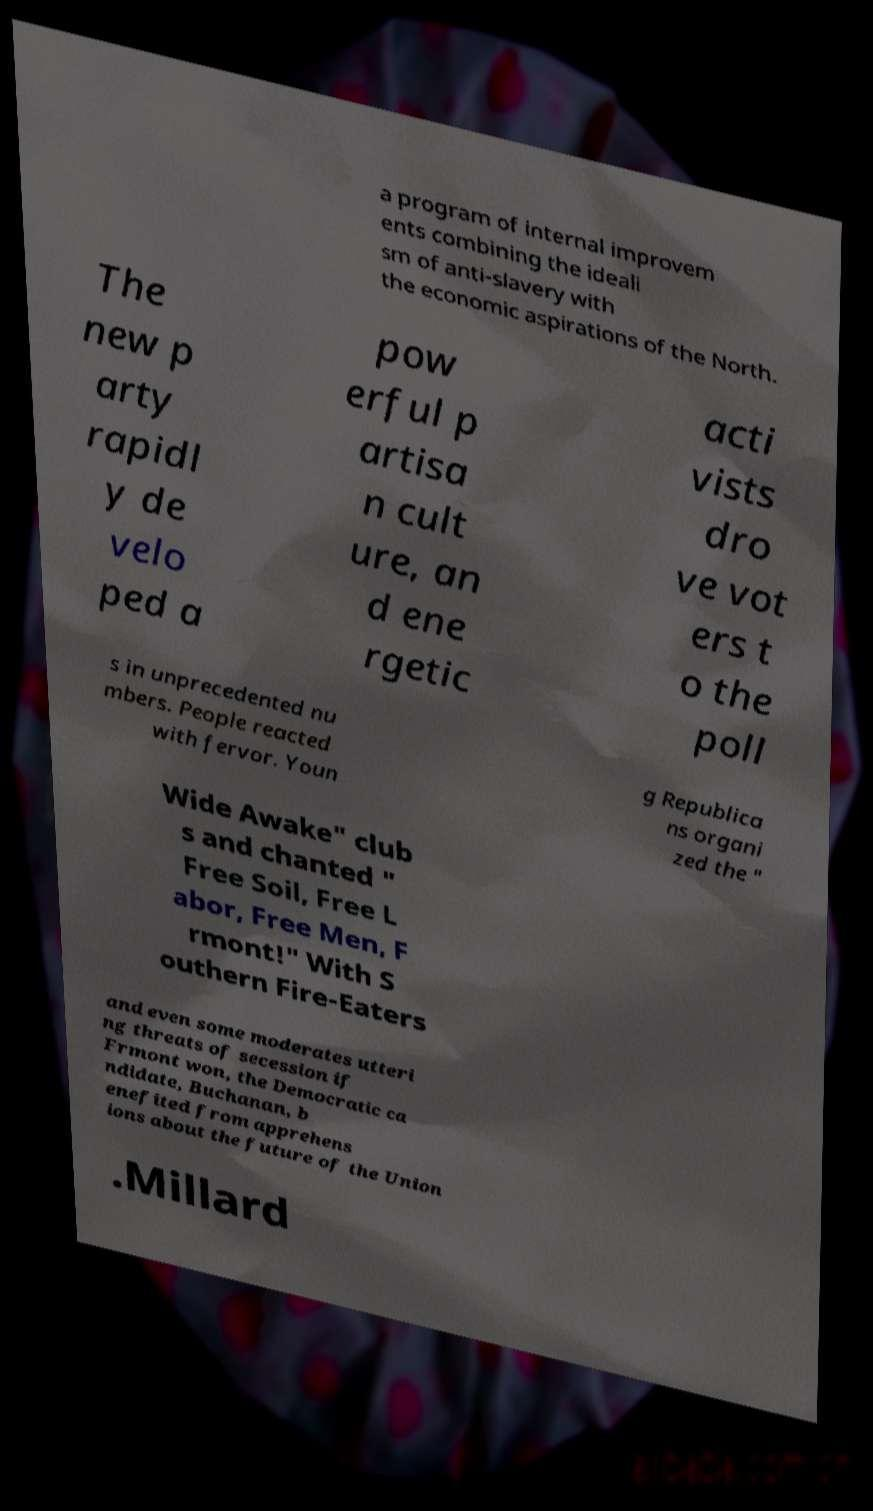For documentation purposes, I need the text within this image transcribed. Could you provide that? a program of internal improvem ents combining the ideali sm of anti-slavery with the economic aspirations of the North. The new p arty rapidl y de velo ped a pow erful p artisa n cult ure, an d ene rgetic acti vists dro ve vot ers t o the poll s in unprecedented nu mbers. People reacted with fervor. Youn g Republica ns organi zed the " Wide Awake" club s and chanted " Free Soil, Free L abor, Free Men, F rmont!" With S outhern Fire-Eaters and even some moderates utteri ng threats of secession if Frmont won, the Democratic ca ndidate, Buchanan, b enefited from apprehens ions about the future of the Union .Millard 